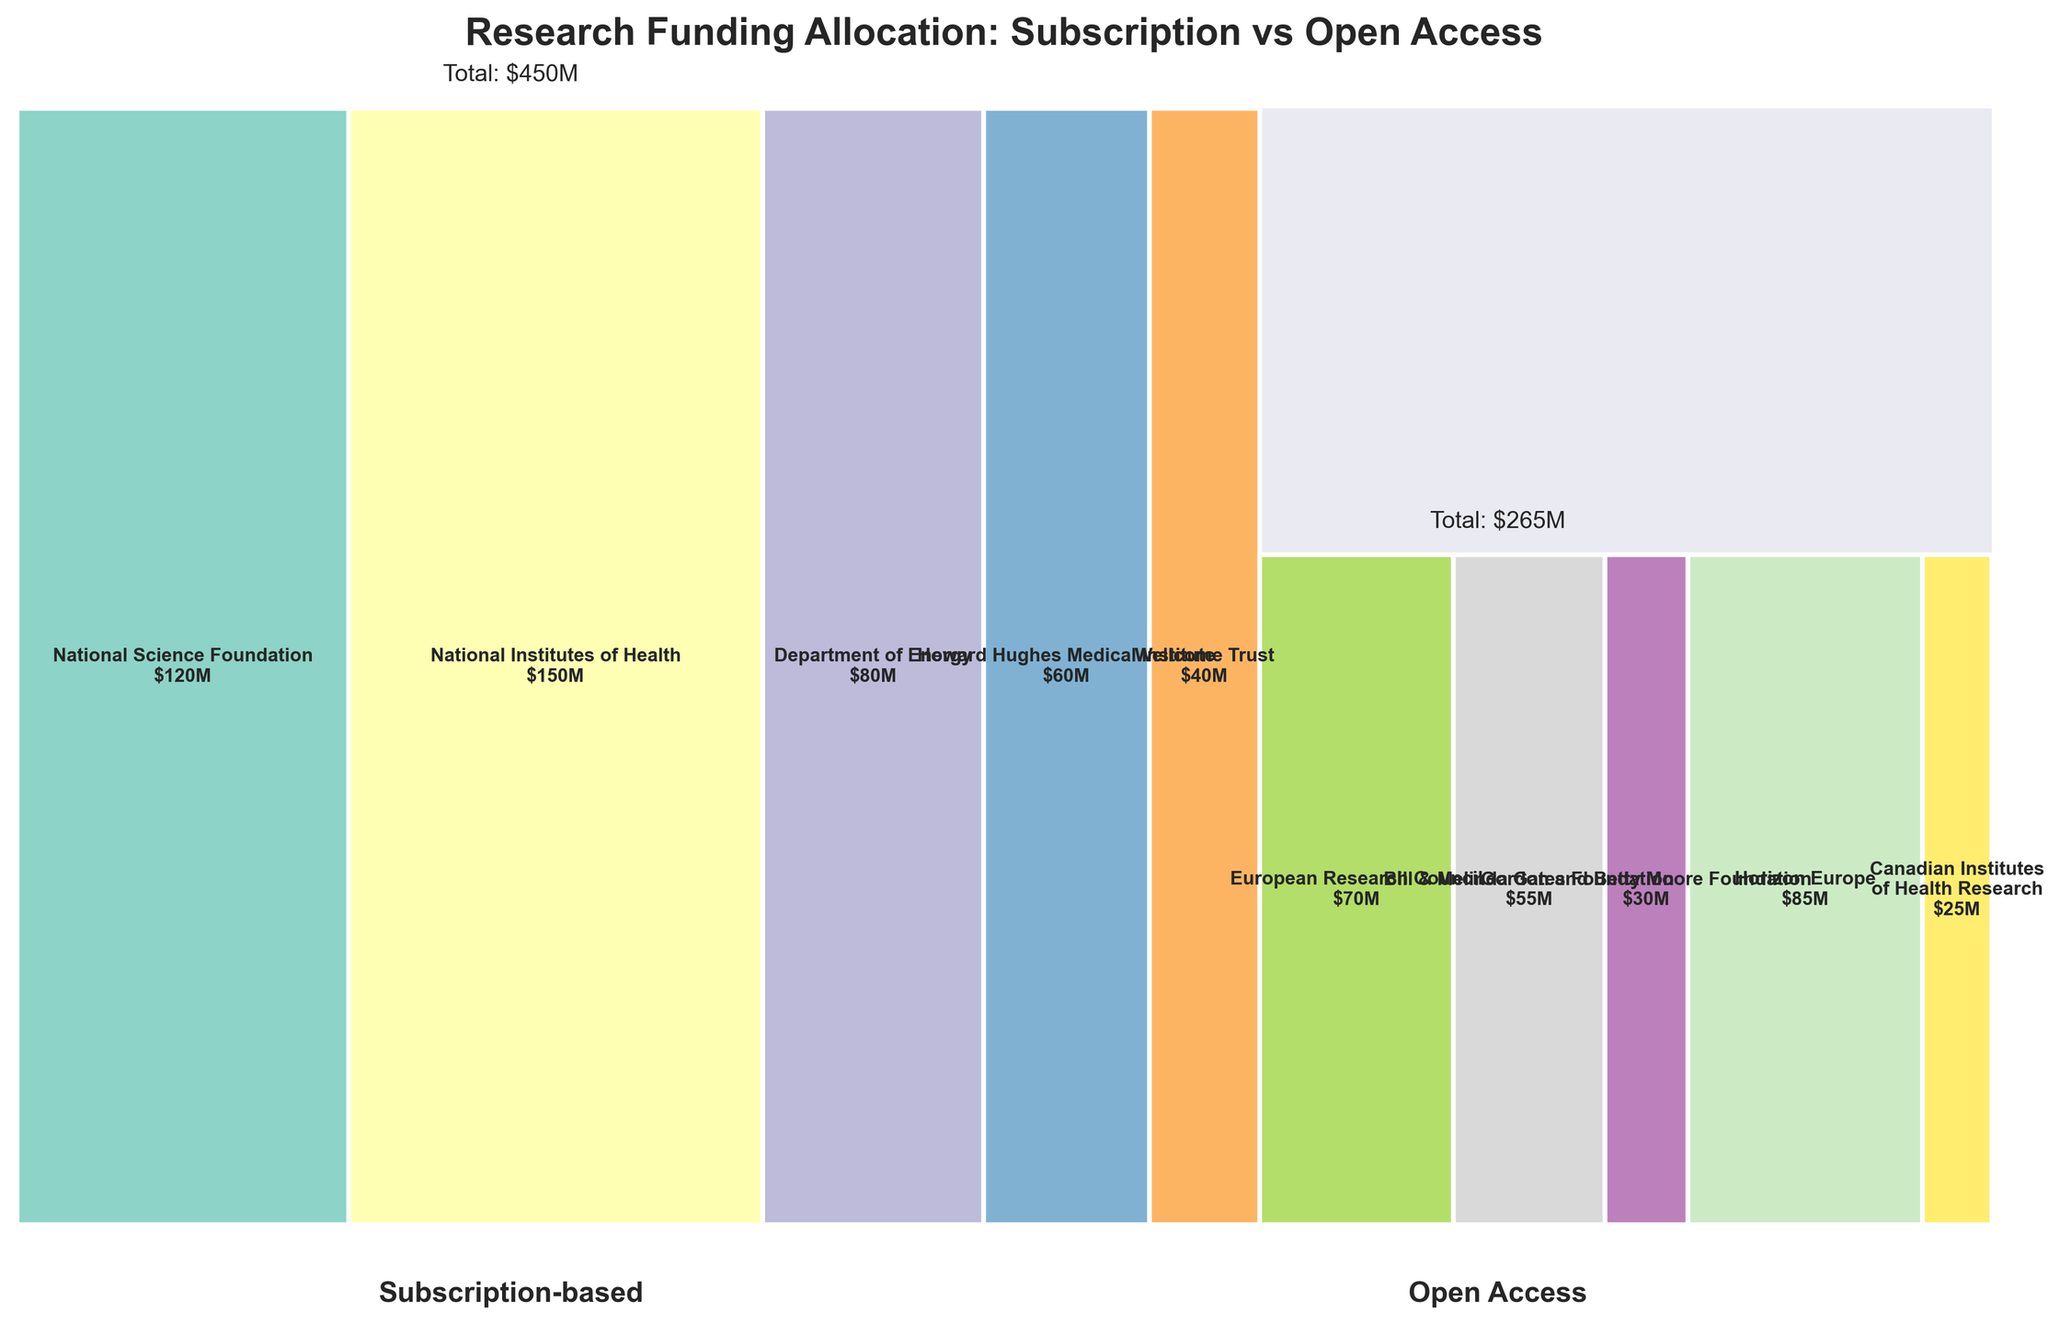What is the title of the figure? The figure's title is centered at the top and reads, "Research Funding Allocation: Subscription vs Open Access."
Answer: Research Funding Allocation: Subscription vs Open Access What is the total funding amount for subscription-based publishing? The total funding amount for subscription-based publishing is listed just below the plot, at the center, as "$450M".
Answer: $450M Which funding source contributed the most to open access publishing initiatives? Among the rectangular patches on the right side (open access), the largest one is labeled "Horizon Europe" with an amount of $85M.
Answer: Horizon Europe How is the total funding for open access divided among various sources? Summing up the contributions for open access: European Research Council ($70M), Bill & Melinda Gates Foundation ($55M), Gordon and Betty Moore Foundation ($30M), Horizon Europe ($85M), and Canadian Institutes of Health Research ($25M). This gives a total of $265M.
Answer: $265M What percentage of total research funding is allocated to subscription-based publishing? The total funding is $715M ($450M for subscription + $265M for open access). The percentage for subscription is ($450M / $715M) * 100%.
Answer: 62.94% Which funding source has the smallest contribution to subscription-based publishing, and how much is it? On the left side (subscription-based), the smallest rectangular patch is labeled "Wellcome Trust" with an amount of $40M.
Answer: Wellcome Trust, $40M How does the funding from the National Science Foundation compare to the funding from Horizon Europe? The National Science Foundation provides $120M, which is less than Horizon Europe's $85M.
Answer: More What’s the difference in total funding between subscription-based and open access publishing? Total funding for subscription-based publishing is $450M, and for open access, it is $265M. The difference is $450M - $265M.
Answer: $185M Which has a higher proportion of the total funding: the National Institutes of Health or the Bill & Melinda Gates Foundation? National Institutes of Health contributes $150M, and Bill & Melinda Gates Foundation provides $55M. $150M is a higher proportion of the total funding of $715M compared to $55M.
Answer: National Institutes of Health 